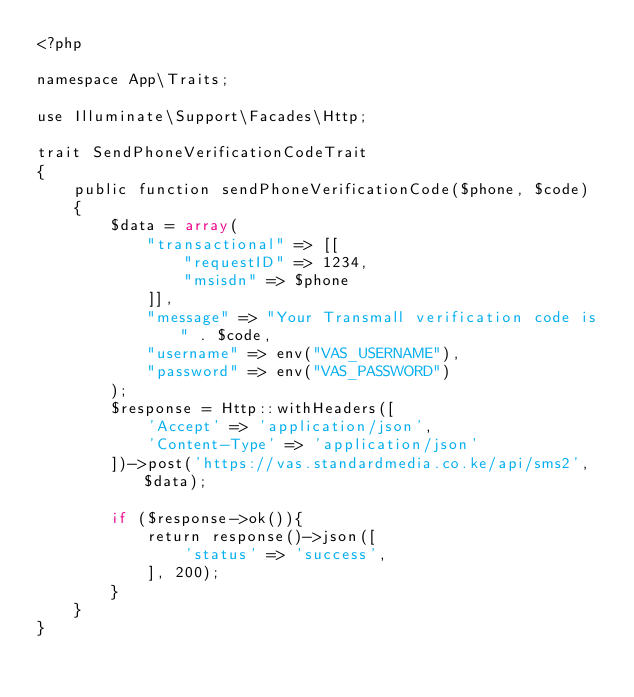Convert code to text. <code><loc_0><loc_0><loc_500><loc_500><_PHP_><?php

namespace App\Traits;

use Illuminate\Support\Facades\Http;

trait SendPhoneVerificationCodeTrait
{
    public function sendPhoneVerificationCode($phone, $code)
    {
        $data = array(
            "transactional" => [[
                "requestID" => 1234,
                "msisdn" => $phone
            ]],
            "message" => "Your Transmall verification code is " . $code,
            "username" => env("VAS_USERNAME"),
            "password" => env("VAS_PASSWORD")
        );
        $response = Http::withHeaders([
            'Accept' => 'application/json',
            'Content-Type' => 'application/json'
        ])->post('https://vas.standardmedia.co.ke/api/sms2', $data);

        if ($response->ok()){
            return response()->json([
                'status' => 'success',
            ], 200);
        }
    }
}
</code> 